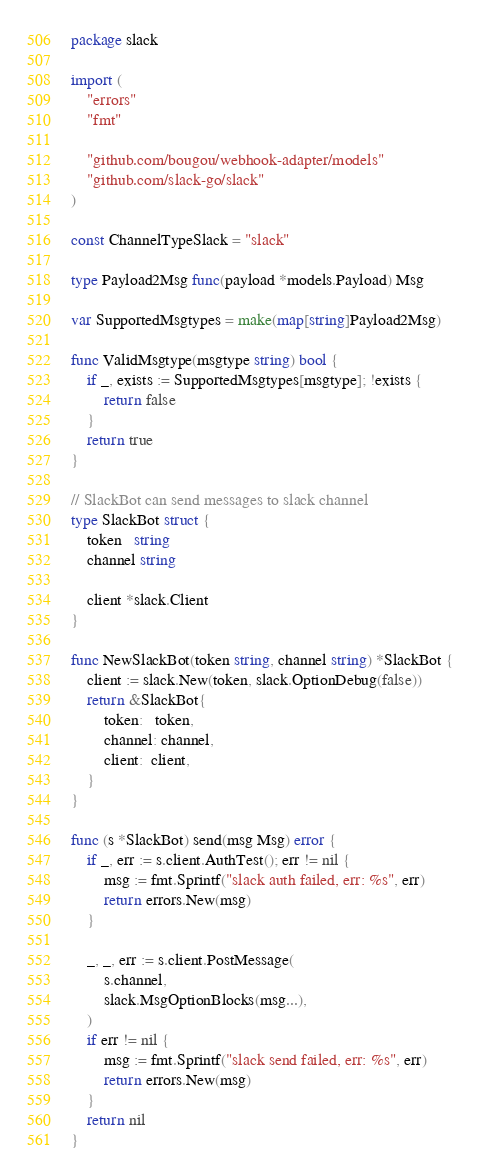<code> <loc_0><loc_0><loc_500><loc_500><_Go_>package slack

import (
	"errors"
	"fmt"

	"github.com/bougou/webhook-adapter/models"
	"github.com/slack-go/slack"
)

const ChannelTypeSlack = "slack"

type Payload2Msg func(payload *models.Payload) Msg

var SupportedMsgtypes = make(map[string]Payload2Msg)

func ValidMsgtype(msgtype string) bool {
	if _, exists := SupportedMsgtypes[msgtype]; !exists {
		return false
	}
	return true
}

// SlackBot can send messages to slack channel
type SlackBot struct {
	token   string
	channel string

	client *slack.Client
}

func NewSlackBot(token string, channel string) *SlackBot {
	client := slack.New(token, slack.OptionDebug(false))
	return &SlackBot{
		token:   token,
		channel: channel,
		client:  client,
	}
}

func (s *SlackBot) send(msg Msg) error {
	if _, err := s.client.AuthTest(); err != nil {
		msg := fmt.Sprintf("slack auth failed, err: %s", err)
		return errors.New(msg)
	}

	_, _, err := s.client.PostMessage(
		s.channel,
		slack.MsgOptionBlocks(msg...),
	)
	if err != nil {
		msg := fmt.Sprintf("slack send failed, err: %s", err)
		return errors.New(msg)
	}
	return nil
}
</code> 